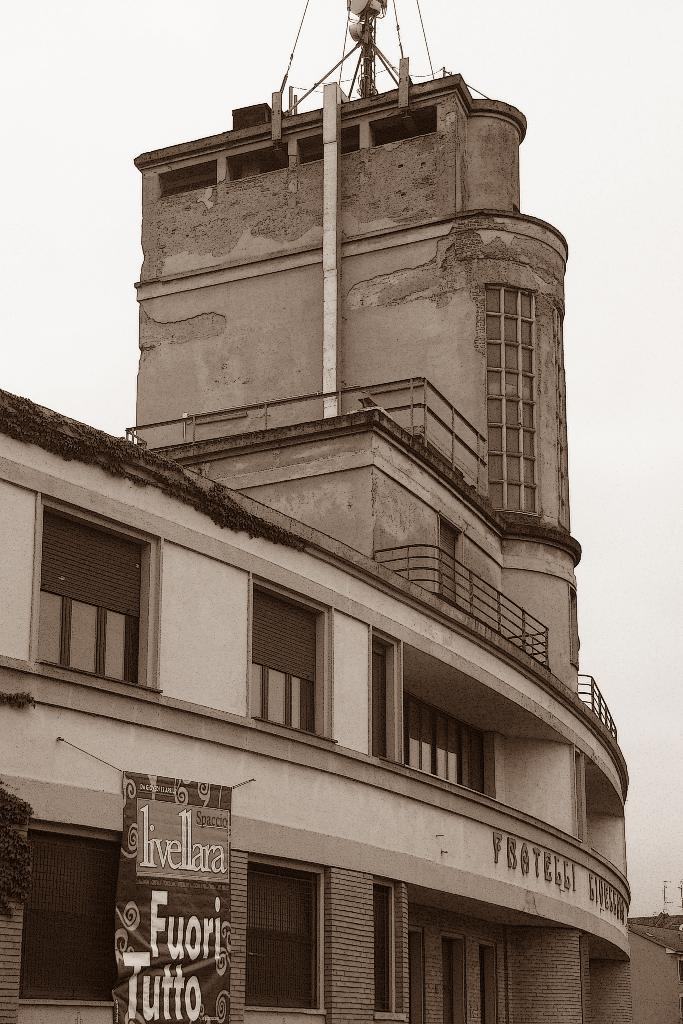What type of structure is present in the image? There is a building in the image. What is attached to the building? There is a banner on the building. What can be seen at the top of the building? There are objects at the top of the building. What is visible in the background of the image? The sky is visible behind the building. What is the weight of the seed that is growing on the building? There is no seed growing on the building in the image, so it is not possible to determine its weight. 